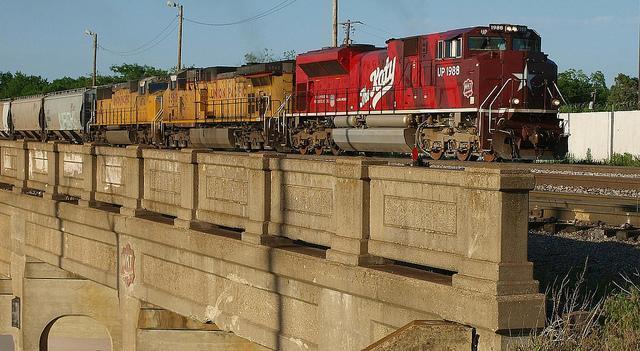How many trains are there?
Give a very brief answer. 1. How many ties are there?
Give a very brief answer. 0. 